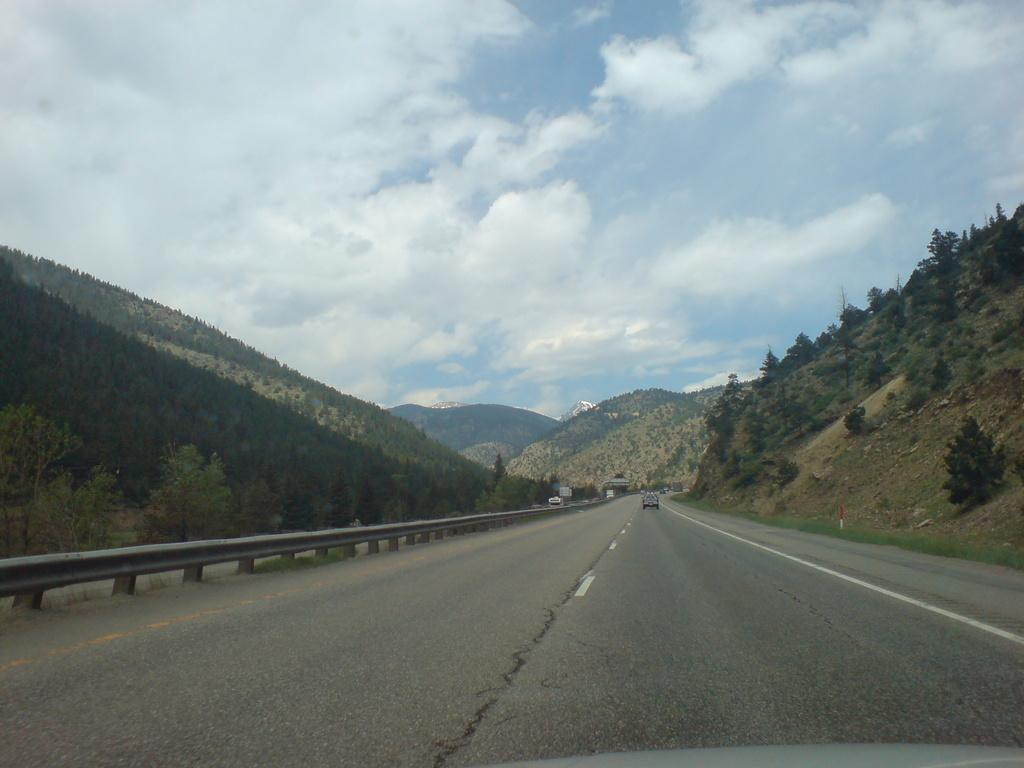What is the main subject of the image? There is a vehicle on the road in the image. What safety feature is present alongside the road? There is a metal beam crash barrier in the image. What type of natural landscape can be seen in the image? There are hills with trees in the image. What is visible in the background of the image? The sky is visible in the background of the image. What type of vacation destination is depicted in the image? The image does not depict a vacation destination; it shows a vehicle on the road with a metal beam crash barrier, hills with trees, and the sky in the background. 